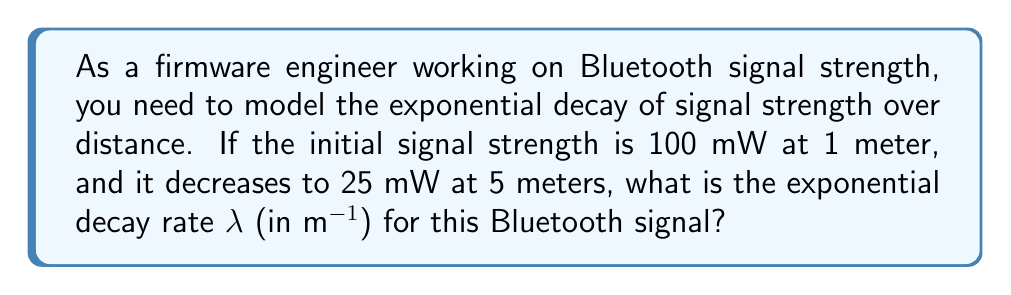Solve this math problem. Let's approach this step-by-step:

1) The general formula for exponential decay is:

   $$P(d) = P_0 e^{-\lambda d}$$

   Where $P(d)$ is the power at distance $d$, $P_0$ is the initial power, and $\lambda$ is the decay rate.

2) We know:
   - $P_0 = 100$ mW (initial power at 1 meter)
   - $P(5) = 25$ mW (power at 5 meters)
   - $d = 5 - 1 = 4$ meters (change in distance)

3) Let's plug these values into the formula:

   $$25 = 100 e^{-\lambda (4)}$$

4) Divide both sides by 100:

   $$0.25 = e^{-4\lambda}$$

5) Take the natural log of both sides:

   $$\ln(0.25) = -4\lambda$$

6) Solve for $\lambda$:

   $$\lambda = -\frac{\ln(0.25)}{4}$$

7) Calculate the value:

   $$\lambda = -\frac{\ln(0.25)}{4} \approx 0.3466 \text{ m}^{-1}$$
Answer: $0.3466 \text{ m}^{-1}$ 